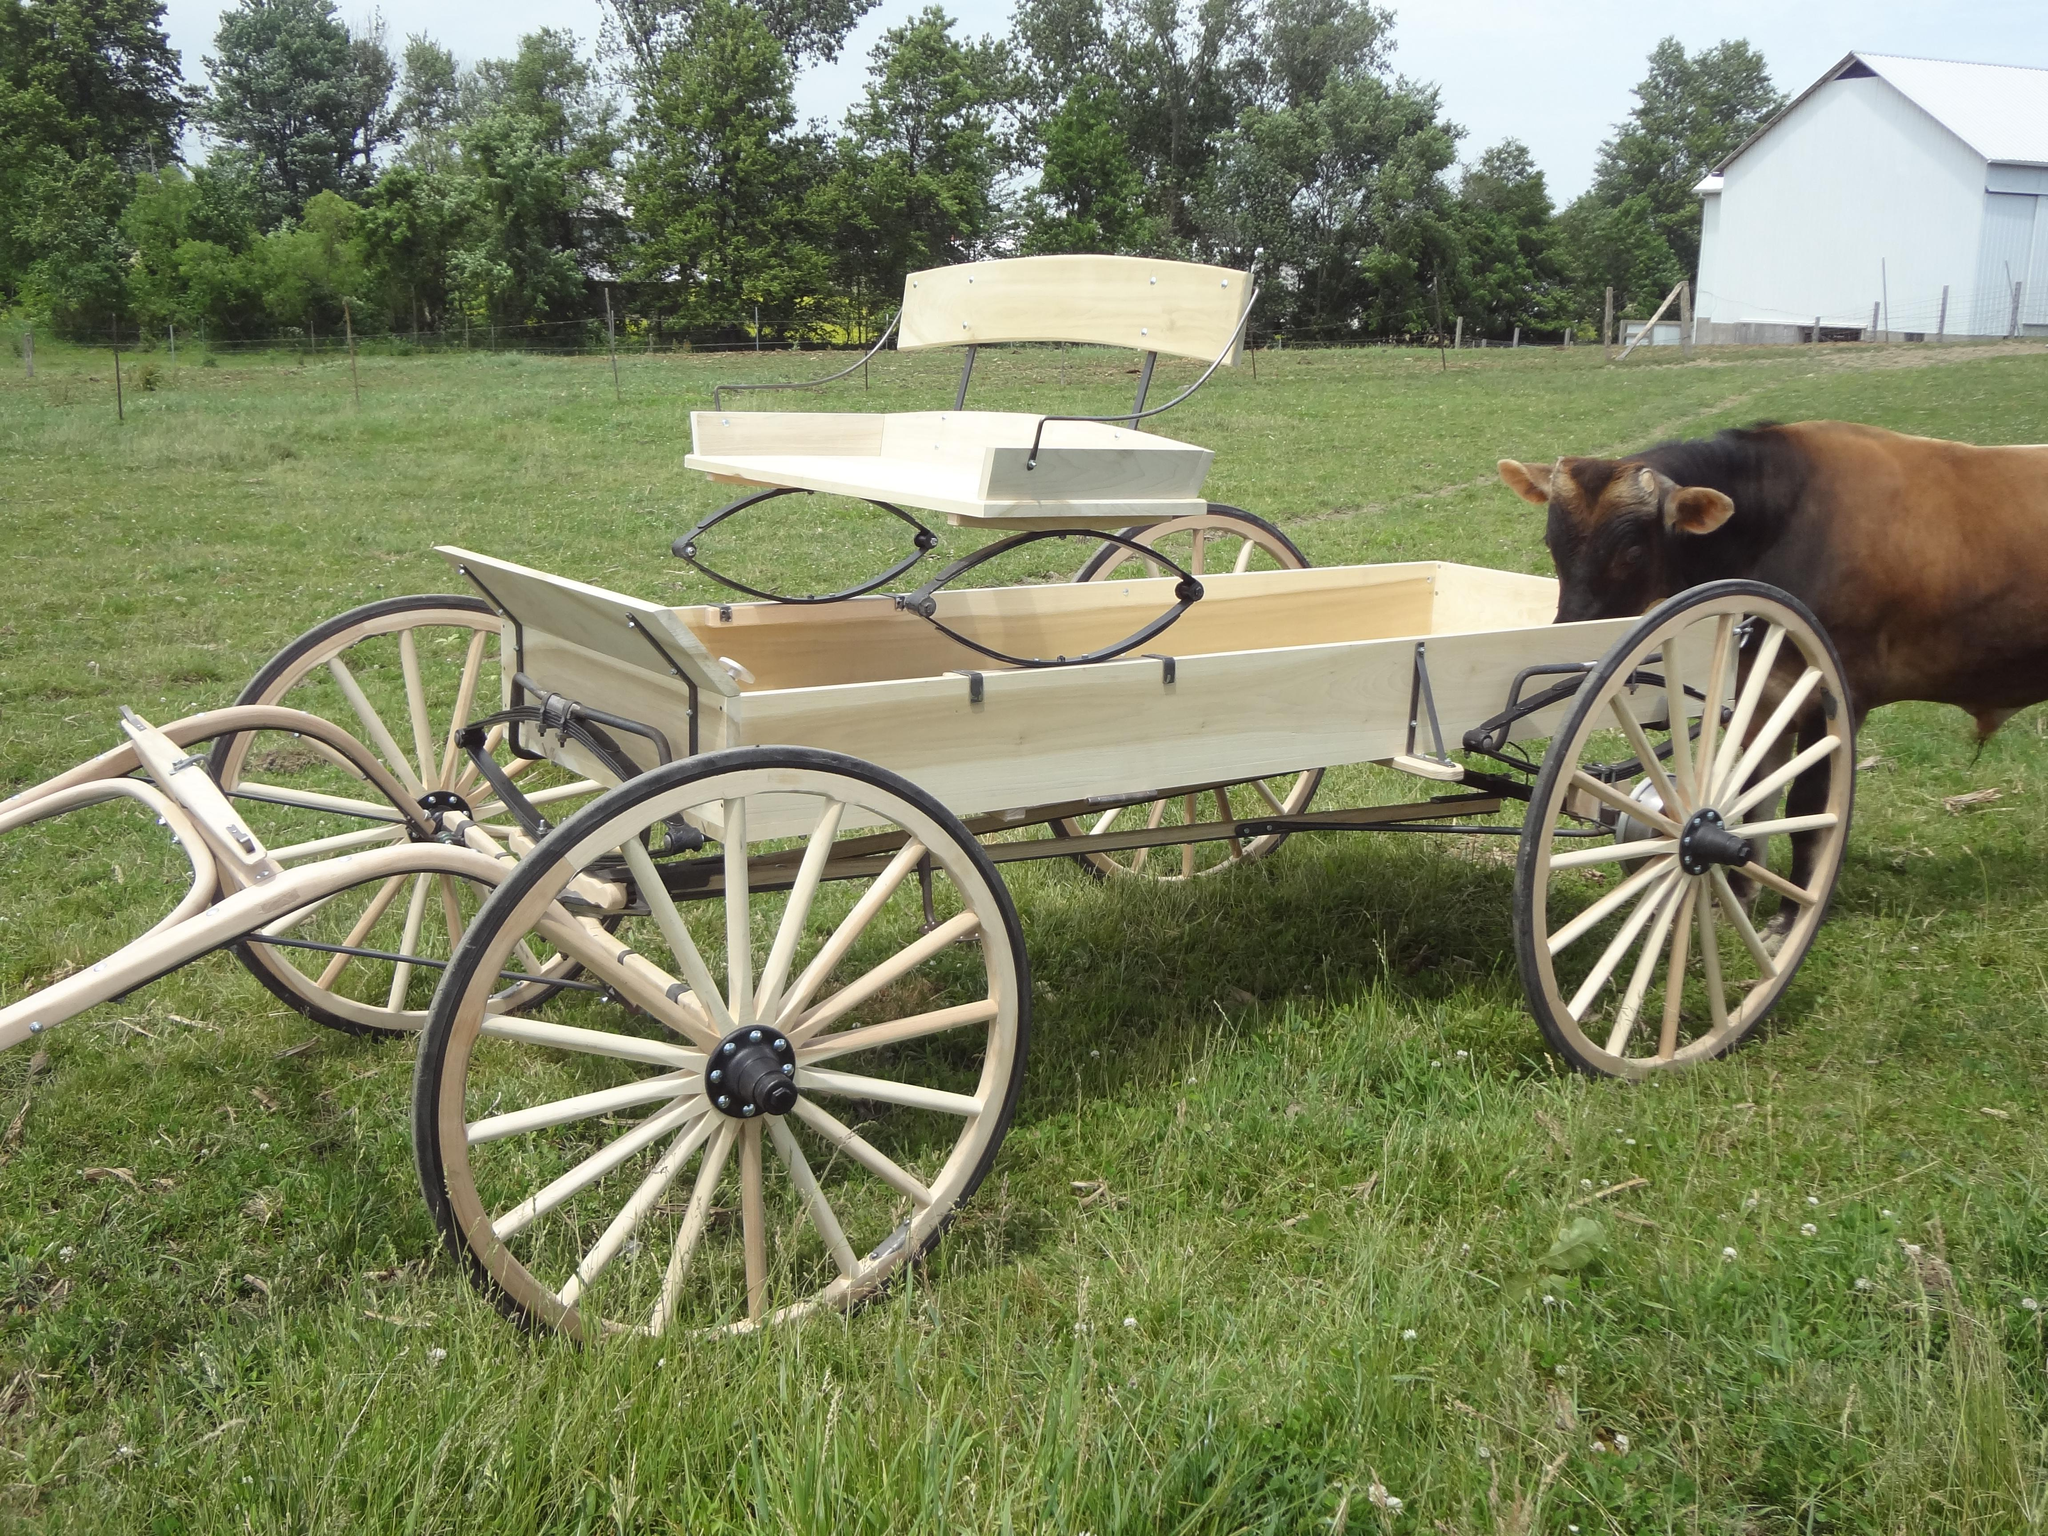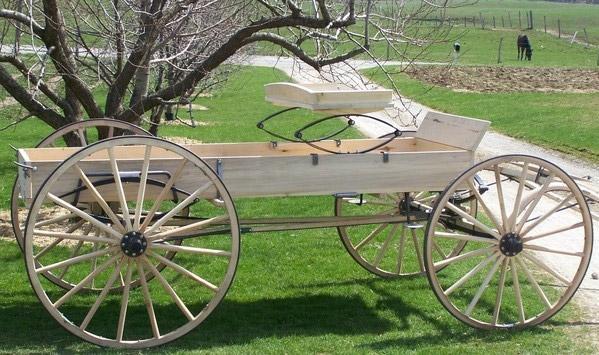The first image is the image on the left, the second image is the image on the right. Analyze the images presented: Is the assertion "A cart in one image is equipped with only two wheels on which are rubber tires." valid? Answer yes or no. No. 